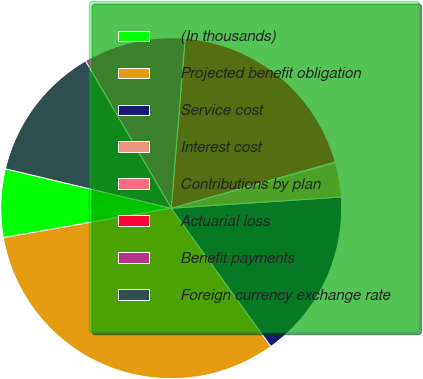Convert chart. <chart><loc_0><loc_0><loc_500><loc_500><pie_chart><fcel>(In thousands)<fcel>Projected benefit obligation<fcel>Service cost<fcel>Interest cost<fcel>Contributions by plan<fcel>Actuarial loss<fcel>Benefit payments<fcel>Foreign currency exchange rate<nl><fcel>6.48%<fcel>32.17%<fcel>16.11%<fcel>3.27%<fcel>0.06%<fcel>19.32%<fcel>9.69%<fcel>12.9%<nl></chart> 